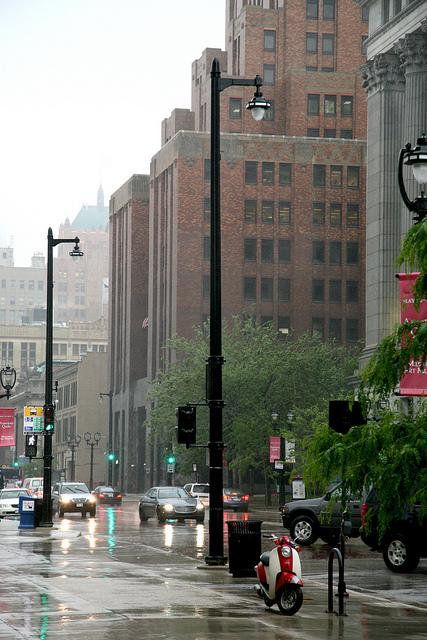What has caused the roads to look reflective? Please explain your reasoning. rain. A warm precipitation event will cause roads to get which, causing them to reflect any available light. motorists should always slow down on wet roads, since sliding and swerving come into play. 